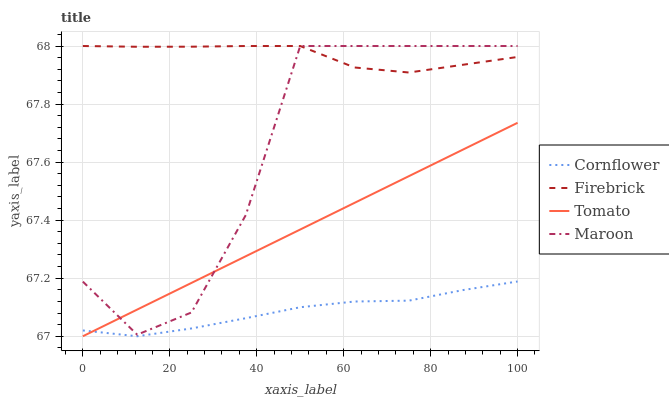Does Cornflower have the minimum area under the curve?
Answer yes or no. Yes. Does Firebrick have the maximum area under the curve?
Answer yes or no. Yes. Does Firebrick have the minimum area under the curve?
Answer yes or no. No. Does Cornflower have the maximum area under the curve?
Answer yes or no. No. Is Tomato the smoothest?
Answer yes or no. Yes. Is Maroon the roughest?
Answer yes or no. Yes. Is Cornflower the smoothest?
Answer yes or no. No. Is Cornflower the roughest?
Answer yes or no. No. Does Tomato have the lowest value?
Answer yes or no. Yes. Does Firebrick have the lowest value?
Answer yes or no. No. Does Maroon have the highest value?
Answer yes or no. Yes. Does Cornflower have the highest value?
Answer yes or no. No. Is Cornflower less than Firebrick?
Answer yes or no. Yes. Is Firebrick greater than Tomato?
Answer yes or no. Yes. Does Firebrick intersect Maroon?
Answer yes or no. Yes. Is Firebrick less than Maroon?
Answer yes or no. No. Is Firebrick greater than Maroon?
Answer yes or no. No. Does Cornflower intersect Firebrick?
Answer yes or no. No. 